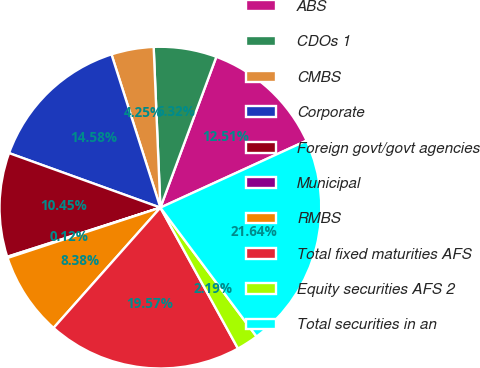Convert chart. <chart><loc_0><loc_0><loc_500><loc_500><pie_chart><fcel>ABS<fcel>CDOs 1<fcel>CMBS<fcel>Corporate<fcel>Foreign govt/govt agencies<fcel>Municipal<fcel>RMBS<fcel>Total fixed maturities AFS<fcel>Equity securities AFS 2<fcel>Total securities in an<nl><fcel>12.51%<fcel>6.32%<fcel>4.25%<fcel>14.58%<fcel>10.45%<fcel>0.12%<fcel>8.38%<fcel>19.57%<fcel>2.19%<fcel>21.64%<nl></chart> 